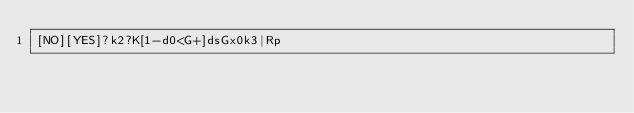Convert code to text. <code><loc_0><loc_0><loc_500><loc_500><_dc_>[NO][YES]?k2?K[1-d0<G+]dsGx0k3|Rp</code> 